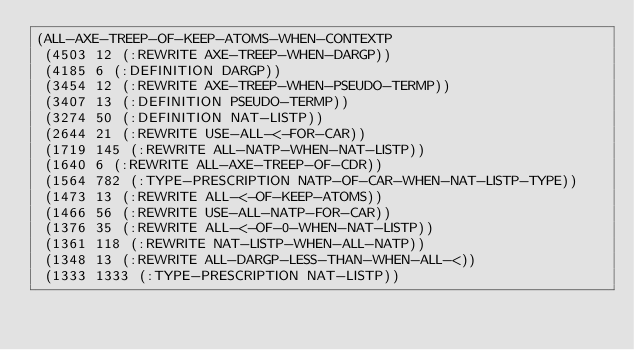<code> <loc_0><loc_0><loc_500><loc_500><_Lisp_>(ALL-AXE-TREEP-OF-KEEP-ATOMS-WHEN-CONTEXTP
 (4503 12 (:REWRITE AXE-TREEP-WHEN-DARGP))
 (4185 6 (:DEFINITION DARGP))
 (3454 12 (:REWRITE AXE-TREEP-WHEN-PSEUDO-TERMP))
 (3407 13 (:DEFINITION PSEUDO-TERMP))
 (3274 50 (:DEFINITION NAT-LISTP))
 (2644 21 (:REWRITE USE-ALL-<-FOR-CAR))
 (1719 145 (:REWRITE ALL-NATP-WHEN-NAT-LISTP))
 (1640 6 (:REWRITE ALL-AXE-TREEP-OF-CDR))
 (1564 782 (:TYPE-PRESCRIPTION NATP-OF-CAR-WHEN-NAT-LISTP-TYPE))
 (1473 13 (:REWRITE ALL-<-OF-KEEP-ATOMS))
 (1466 56 (:REWRITE USE-ALL-NATP-FOR-CAR))
 (1376 35 (:REWRITE ALL-<-OF-0-WHEN-NAT-LISTP))
 (1361 118 (:REWRITE NAT-LISTP-WHEN-ALL-NATP))
 (1348 13 (:REWRITE ALL-DARGP-LESS-THAN-WHEN-ALL-<))
 (1333 1333 (:TYPE-PRESCRIPTION NAT-LISTP))</code> 